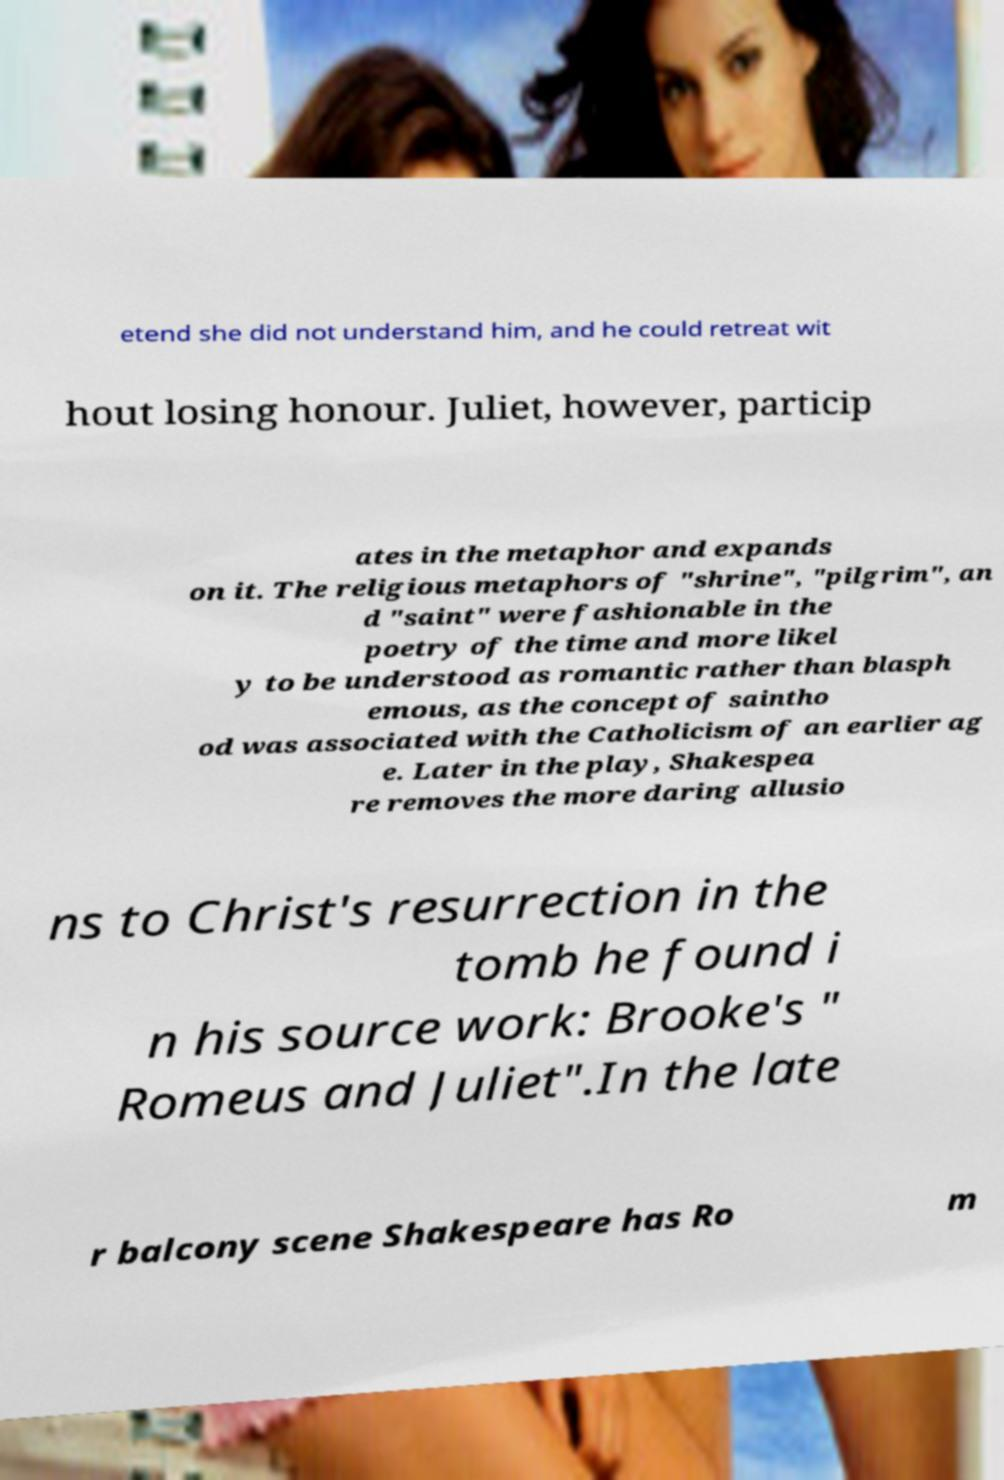I need the written content from this picture converted into text. Can you do that? etend she did not understand him, and he could retreat wit hout losing honour. Juliet, however, particip ates in the metaphor and expands on it. The religious metaphors of "shrine", "pilgrim", an d "saint" were fashionable in the poetry of the time and more likel y to be understood as romantic rather than blasph emous, as the concept of saintho od was associated with the Catholicism of an earlier ag e. Later in the play, Shakespea re removes the more daring allusio ns to Christ's resurrection in the tomb he found i n his source work: Brooke's " Romeus and Juliet".In the late r balcony scene Shakespeare has Ro m 